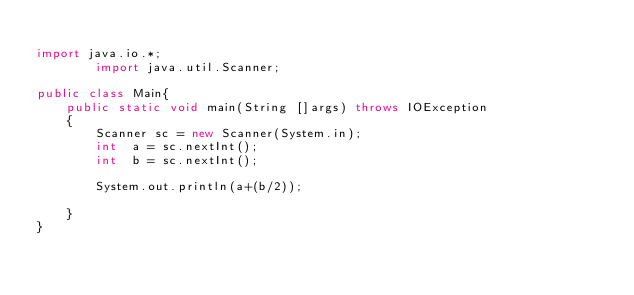Convert code to text. <code><loc_0><loc_0><loc_500><loc_500><_Java_>
import java.io.*;
        import java.util.Scanner;

public class Main{
    public static void main(String []args) throws IOException
    {
        Scanner sc = new Scanner(System.in);
        int  a = sc.nextInt();
        int  b = sc.nextInt();

        System.out.println(a+(b/2));

    }
}</code> 